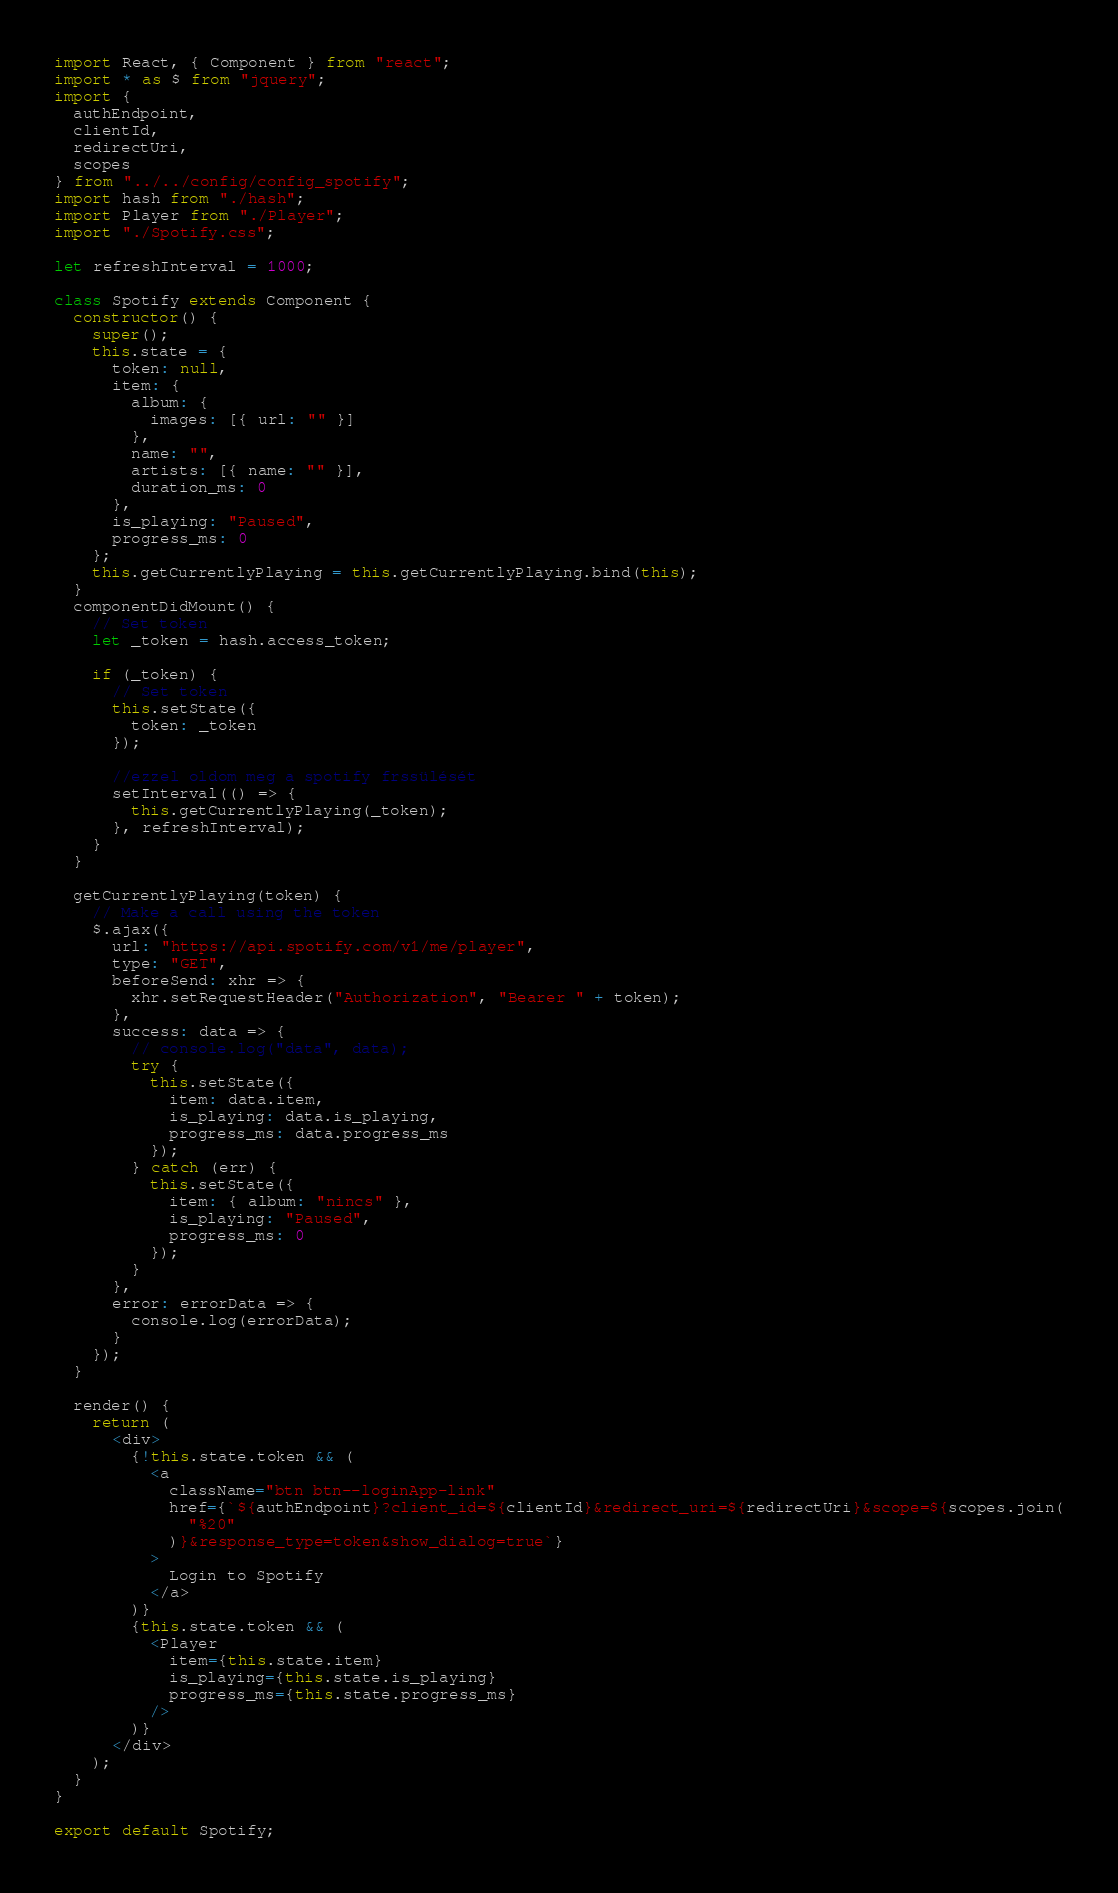<code> <loc_0><loc_0><loc_500><loc_500><_JavaScript_>import React, { Component } from "react";
import * as $ from "jquery";
import {
  authEndpoint,
  clientId,
  redirectUri,
  scopes
} from "../../config/config_spotify";
import hash from "./hash";
import Player from "./Player";
import "./Spotify.css";

let refreshInterval = 1000;

class Spotify extends Component {
  constructor() {
    super();
    this.state = {
      token: null,
      item: {
        album: {
          images: [{ url: "" }]
        },
        name: "",
        artists: [{ name: "" }],
        duration_ms: 0
      },
      is_playing: "Paused",
      progress_ms: 0
    };
    this.getCurrentlyPlaying = this.getCurrentlyPlaying.bind(this);
  }
  componentDidMount() {
    // Set token
    let _token = hash.access_token;

    if (_token) {
      // Set token
      this.setState({
        token: _token
      });

      //ezzel oldom meg a spotify frssülését
      setInterval(() => {
        this.getCurrentlyPlaying(_token);
      }, refreshInterval);
    }
  }

  getCurrentlyPlaying(token) {
    // Make a call using the token
    $.ajax({
      url: "https://api.spotify.com/v1/me/player",
      type: "GET",
      beforeSend: xhr => {
        xhr.setRequestHeader("Authorization", "Bearer " + token);
      },
      success: data => {
        // console.log("data", data);
        try {
          this.setState({
            item: data.item,
            is_playing: data.is_playing,
            progress_ms: data.progress_ms
          });
        } catch (err) {
          this.setState({
            item: { album: "nincs" },
            is_playing: "Paused",
            progress_ms: 0
          });
        }
      },
      error: errorData => {
        console.log(errorData);
      }
    });
  }

  render() {
    return (
      <div>
        {!this.state.token && (
          <a
            className="btn btn--loginApp-link"
            href={`${authEndpoint}?client_id=${clientId}&redirect_uri=${redirectUri}&scope=${scopes.join(
              "%20"
            )}&response_type=token&show_dialog=true`}
          >
            Login to Spotify
          </a>
        )}
        {this.state.token && (
          <Player
            item={this.state.item}
            is_playing={this.state.is_playing}
            progress_ms={this.state.progress_ms}
          />
        )}
      </div>
    );
  }
}

export default Spotify;
</code> 